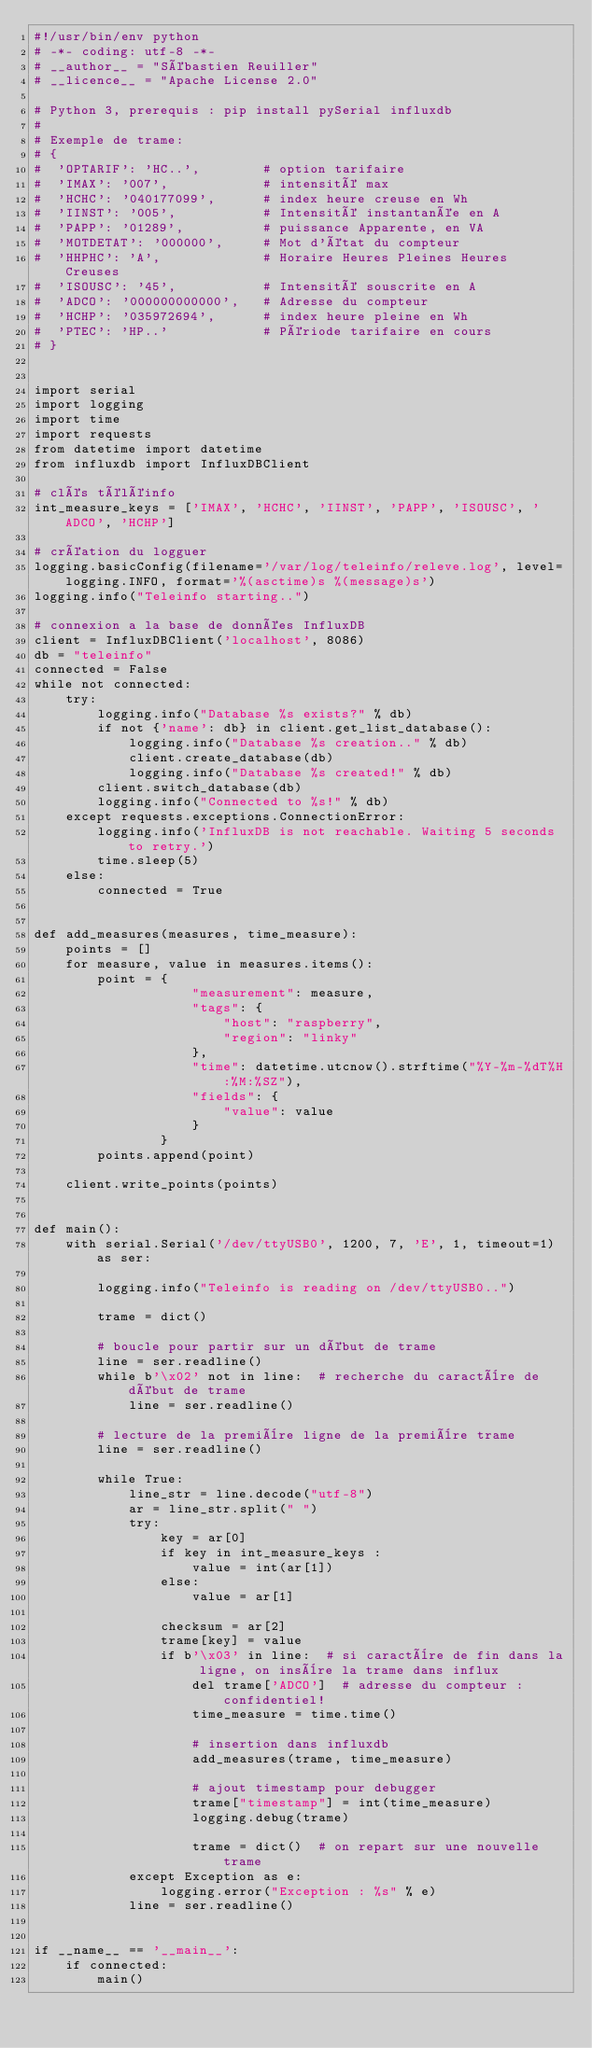Convert code to text. <code><loc_0><loc_0><loc_500><loc_500><_Python_>#!/usr/bin/env python
# -*- coding: utf-8 -*-
# __author__ = "Sébastien Reuiller"
# __licence__ = "Apache License 2.0"

# Python 3, prerequis : pip install pySerial influxdb
#
# Exemple de trame:
# {
#  'OPTARIF': 'HC..',        # option tarifaire
#  'IMAX': '007',            # intensité max
#  'HCHC': '040177099',      # index heure creuse en Wh
#  'IINST': '005',           # Intensité instantanée en A
#  'PAPP': '01289',          # puissance Apparente, en VA
#  'MOTDETAT': '000000',     # Mot d'état du compteur
#  'HHPHC': 'A',             # Horaire Heures Pleines Heures Creuses
#  'ISOUSC': '45',           # Intensité souscrite en A
#  'ADCO': '000000000000',   # Adresse du compteur
#  'HCHP': '035972694',      # index heure pleine en Wh
#  'PTEC': 'HP..'            # Période tarifaire en cours
# }


import serial
import logging
import time
import requests
from datetime import datetime
from influxdb import InfluxDBClient

# clés téléinfo
int_measure_keys = ['IMAX', 'HCHC', 'IINST', 'PAPP', 'ISOUSC', 'ADCO', 'HCHP']

# création du logguer
logging.basicConfig(filename='/var/log/teleinfo/releve.log', level=logging.INFO, format='%(asctime)s %(message)s')
logging.info("Teleinfo starting..")

# connexion a la base de données InfluxDB
client = InfluxDBClient('localhost', 8086)
db = "teleinfo"
connected = False
while not connected:
    try:
        logging.info("Database %s exists?" % db)
        if not {'name': db} in client.get_list_database():
            logging.info("Database %s creation.." % db)
            client.create_database(db)
            logging.info("Database %s created!" % db)
        client.switch_database(db)
        logging.info("Connected to %s!" % db)
    except requests.exceptions.ConnectionError:
        logging.info('InfluxDB is not reachable. Waiting 5 seconds to retry.')
        time.sleep(5)
    else:
        connected = True


def add_measures(measures, time_measure):
    points = []
    for measure, value in measures.items():
        point = {
                    "measurement": measure,
                    "tags": {
                        "host": "raspberry",
                        "region": "linky"
                    },
                    "time": datetime.utcnow().strftime("%Y-%m-%dT%H:%M:%SZ"),
                    "fields": {
                        "value": value
                    }
                }
        points.append(point)

    client.write_points(points)


def main():
    with serial.Serial('/dev/ttyUSB0', 1200, 7, 'E', 1, timeout=1) as ser:

        logging.info("Teleinfo is reading on /dev/ttyUSB0..")

        trame = dict()

        # boucle pour partir sur un début de trame
        line = ser.readline()
        while b'\x02' not in line:  # recherche du caractère de début de trame
            line = ser.readline()

        # lecture de la première ligne de la première trame
        line = ser.readline()

        while True:
            line_str = line.decode("utf-8")
            ar = line_str.split(" ")
            try:
                key = ar[0]
                if key in int_measure_keys :
                    value = int(ar[1])
                else:
                    value = ar[1]

                checksum = ar[2]
                trame[key] = value
                if b'\x03' in line:  # si caractère de fin dans la ligne, on insère la trame dans influx
                    del trame['ADCO']  # adresse du compteur : confidentiel!
                    time_measure = time.time()

                    # insertion dans influxdb
                    add_measures(trame, time_measure)

                    # ajout timestamp pour debugger
                    trame["timestamp"] = int(time_measure)
                    logging.debug(trame)

                    trame = dict()  # on repart sur une nouvelle trame
            except Exception as e:
                logging.error("Exception : %s" % e)
            line = ser.readline()


if __name__ == '__main__':
    if connected:
        main()
</code> 